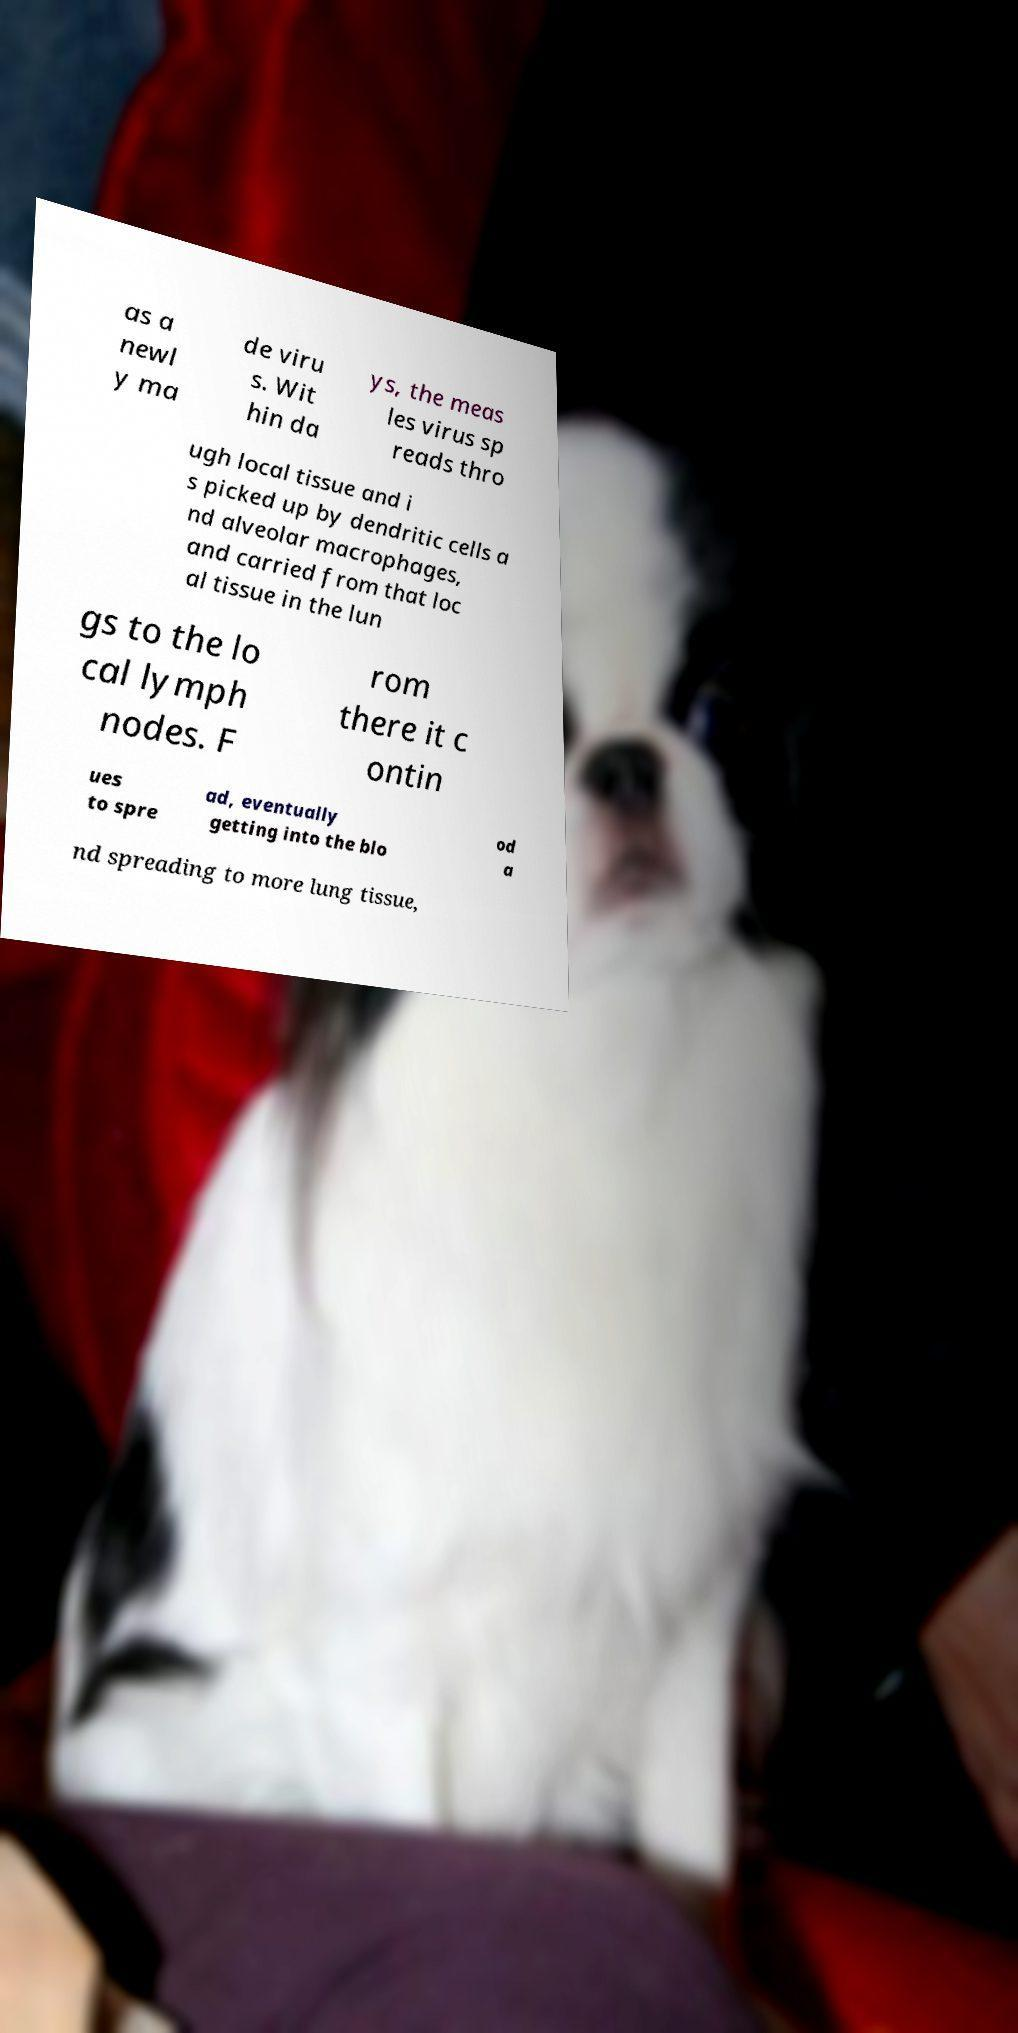For documentation purposes, I need the text within this image transcribed. Could you provide that? as a newl y ma de viru s. Wit hin da ys, the meas les virus sp reads thro ugh local tissue and i s picked up by dendritic cells a nd alveolar macrophages, and carried from that loc al tissue in the lun gs to the lo cal lymph nodes. F rom there it c ontin ues to spre ad, eventually getting into the blo od a nd spreading to more lung tissue, 